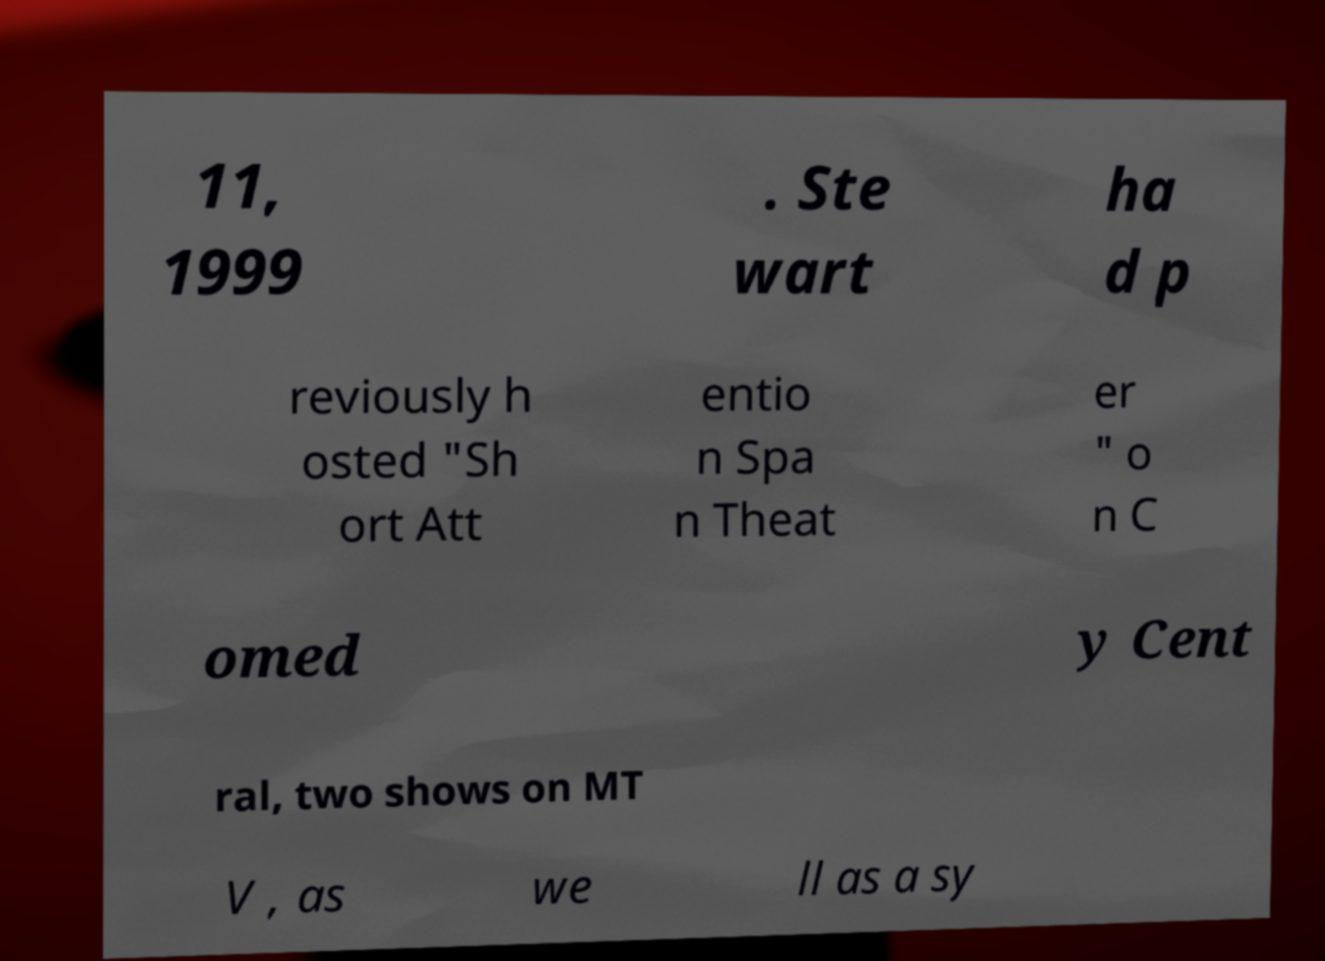Please identify and transcribe the text found in this image. 11, 1999 . Ste wart ha d p reviously h osted "Sh ort Att entio n Spa n Theat er " o n C omed y Cent ral, two shows on MT V , as we ll as a sy 